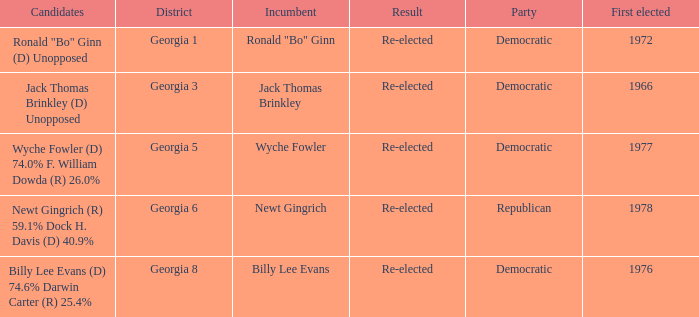In 1972, how many candidates were elected for the first time? 1.0. 